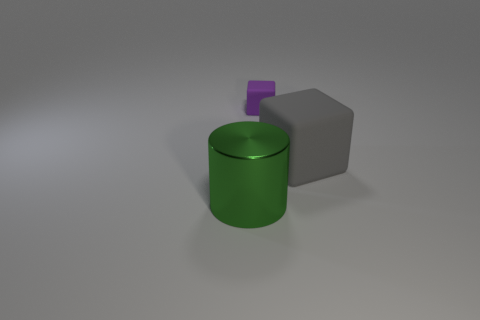Is there anything else that has the same size as the purple thing?
Offer a terse response. No. Are there any other things that have the same color as the metal cylinder?
Ensure brevity in your answer.  No. What is the object in front of the gray rubber cube made of?
Offer a very short reply. Metal. Is the size of the purple matte thing the same as the cylinder?
Provide a short and direct response. No. How many other objects are there of the same size as the green shiny cylinder?
Ensure brevity in your answer.  1. Do the large shiny object and the small block have the same color?
Provide a succinct answer. No. What is the shape of the rubber object that is on the left side of the rubber thing that is right of the matte cube that is behind the gray thing?
Your answer should be compact. Cube. How many objects are either rubber blocks that are on the left side of the large gray object or large objects that are to the right of the big cylinder?
Ensure brevity in your answer.  2. What is the size of the object behind the large object that is behind the large green cylinder?
Your answer should be very brief. Small. Is the color of the big object on the right side of the big green metal object the same as the metal cylinder?
Provide a short and direct response. No. 